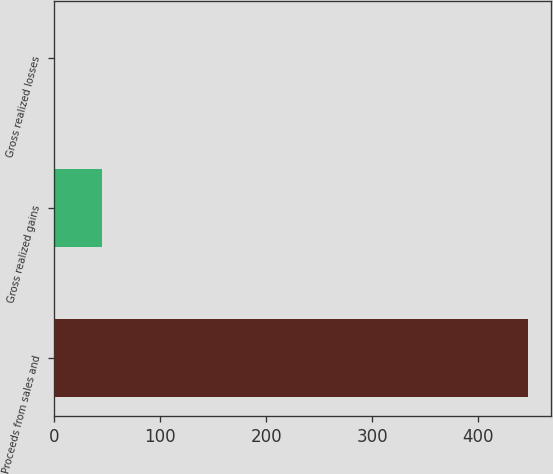Convert chart to OTSL. <chart><loc_0><loc_0><loc_500><loc_500><bar_chart><fcel>Proceeds from sales and<fcel>Gross realized gains<fcel>Gross realized losses<nl><fcel>446.4<fcel>45<fcel>0.4<nl></chart> 